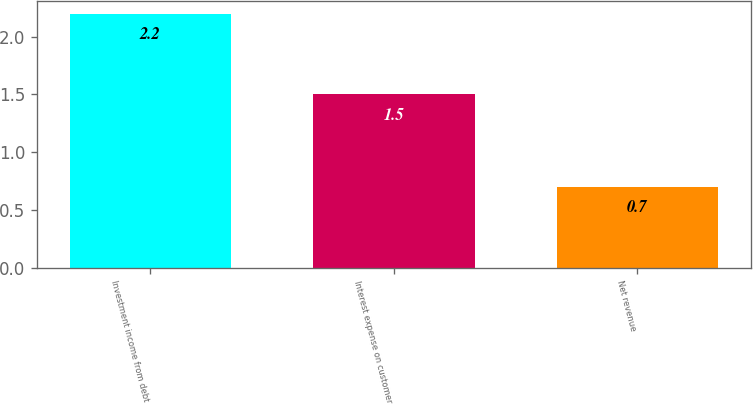Convert chart to OTSL. <chart><loc_0><loc_0><loc_500><loc_500><bar_chart><fcel>Investment income from debt<fcel>Interest expense on customer<fcel>Net revenue<nl><fcel>2.2<fcel>1.5<fcel>0.7<nl></chart> 